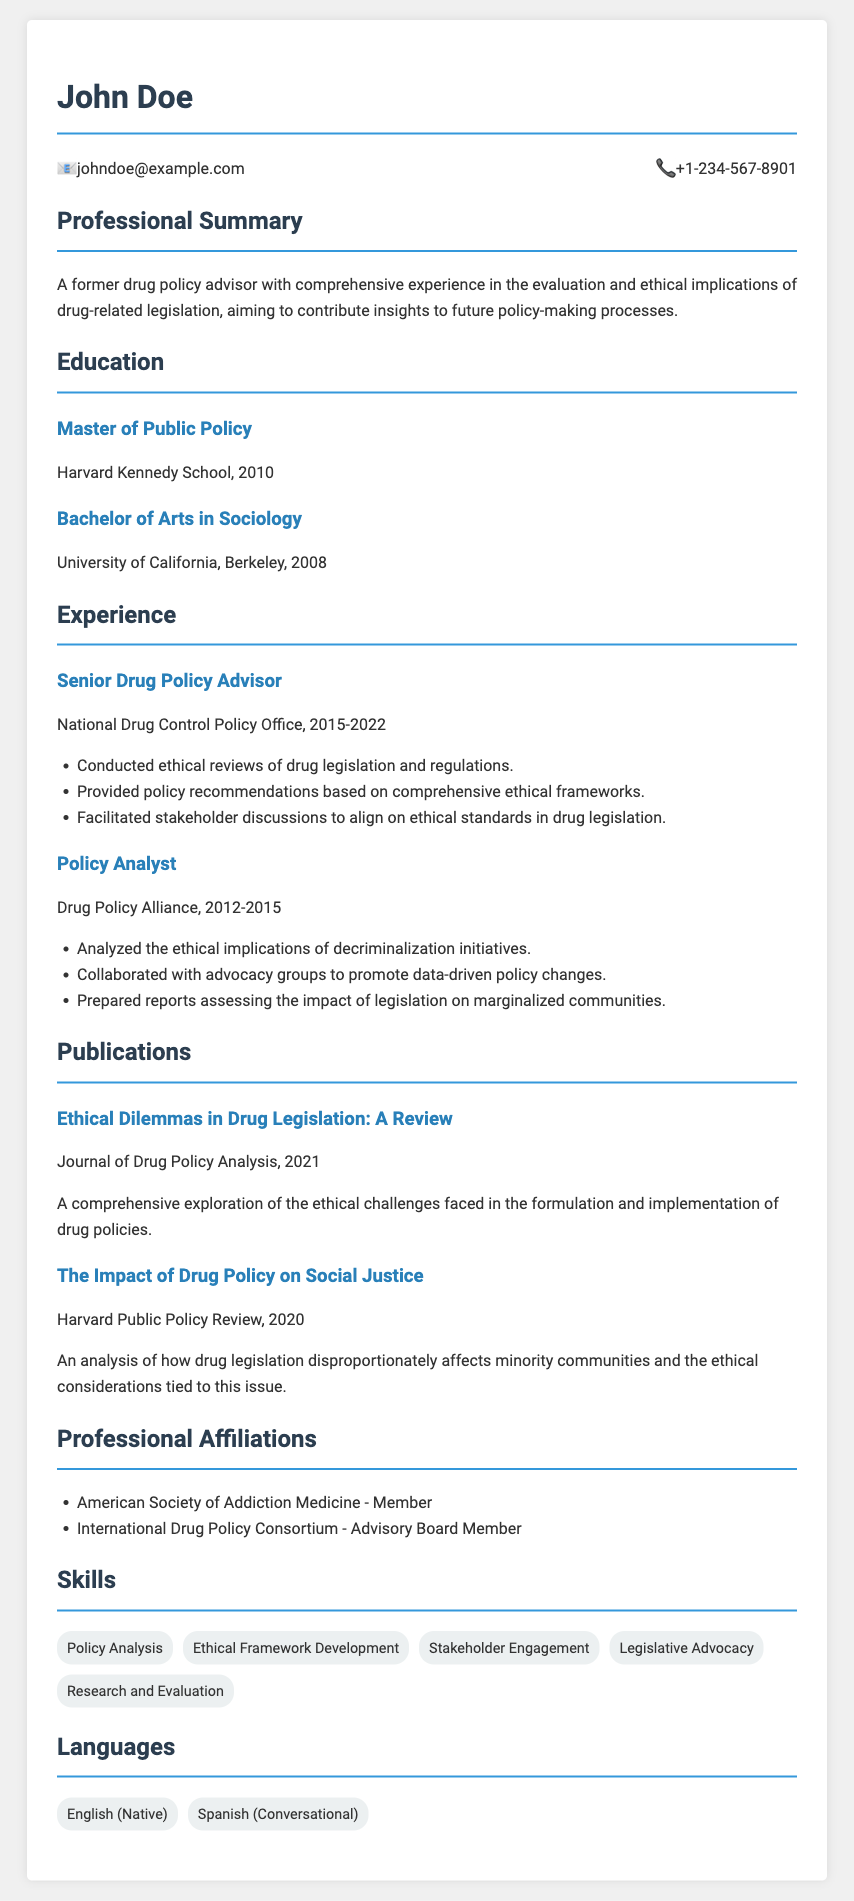What is the name of the individual in the CV? The name of the individual is presented at the top of the document.
Answer: John Doe What is the contact email provided in the CV? The contact email is included in the contact information section.
Answer: johndoe@example.com What year did the individual graduate with a Master of Public Policy? The graduation year for the Master of Public Policy is listed in the education section.
Answer: 2010 In which office did John Doe work as a Senior Drug Policy Advisor? This information is found in the experience section detailing the job title and organization.
Answer: National Drug Control Policy Office What publication discusses ethical dilemmas in drug legislation? The name of the publication is listed in the publications section.
Answer: Ethical Dilemmas in Drug Legislation: A Review How many years of experience did John Doe have at the National Drug Control Policy Office? The experience timeline is detailed by the start and end years provided in the CV.
Answer: 7 years What skill related to drug policy analysis does John Doe possess? The skills section lists various skills, including relevant areas of expertise.
Answer: Ethical Framework Development Which language is listed as conversational? The languages section specifies the proficiency level of different languages spoken.
Answer: Spanish In what year was "The Impact of Drug Policy on Social Justice" published? The year of publication can be found alongside the article title in the publications section.
Answer: 2020 